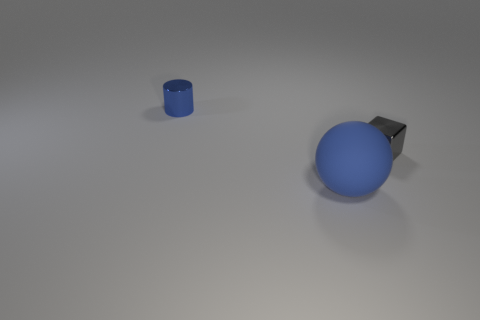Add 2 green shiny blocks. How many objects exist? 5 Subtract all blocks. How many objects are left? 2 Add 1 metallic cubes. How many metallic cubes exist? 2 Subtract 1 blue spheres. How many objects are left? 2 Subtract all big yellow blocks. Subtract all tiny blue metal cylinders. How many objects are left? 2 Add 3 tiny objects. How many tiny objects are left? 5 